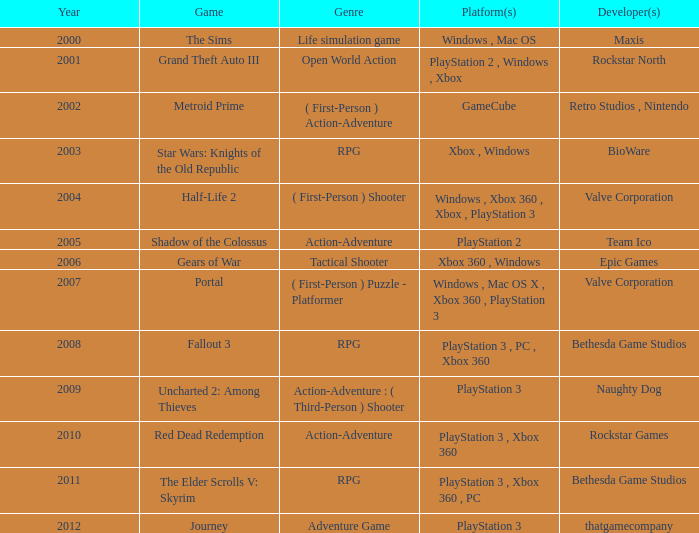What's the genre of The Sims before 2002? Life simulation game. Would you be able to parse every entry in this table? {'header': ['Year', 'Game', 'Genre', 'Platform(s)', 'Developer(s)'], 'rows': [['2000', 'The Sims', 'Life simulation game', 'Windows , Mac OS', 'Maxis'], ['2001', 'Grand Theft Auto III', 'Open World Action', 'PlayStation 2 , Windows , Xbox', 'Rockstar North'], ['2002', 'Metroid Prime', '( First-Person ) Action-Adventure', 'GameCube', 'Retro Studios , Nintendo'], ['2003', 'Star Wars: Knights of the Old Republic', 'RPG', 'Xbox , Windows', 'BioWare'], ['2004', 'Half-Life 2', '( First-Person ) Shooter', 'Windows , Xbox 360 , Xbox , PlayStation 3', 'Valve Corporation'], ['2005', 'Shadow of the Colossus', 'Action-Adventure', 'PlayStation 2', 'Team Ico'], ['2006', 'Gears of War', 'Tactical Shooter', 'Xbox 360 , Windows', 'Epic Games'], ['2007', 'Portal', '( First-Person ) Puzzle - Platformer', 'Windows , Mac OS X , Xbox 360 , PlayStation 3', 'Valve Corporation'], ['2008', 'Fallout 3', 'RPG', 'PlayStation 3 , PC , Xbox 360', 'Bethesda Game Studios'], ['2009', 'Uncharted 2: Among Thieves', 'Action-Adventure : ( Third-Person ) Shooter', 'PlayStation 3', 'Naughty Dog'], ['2010', 'Red Dead Redemption', 'Action-Adventure', 'PlayStation 3 , Xbox 360', 'Rockstar Games'], ['2011', 'The Elder Scrolls V: Skyrim', 'RPG', 'PlayStation 3 , Xbox 360 , PC', 'Bethesda Game Studios'], ['2012', 'Journey', 'Adventure Game', 'PlayStation 3', 'thatgamecompany']]} 